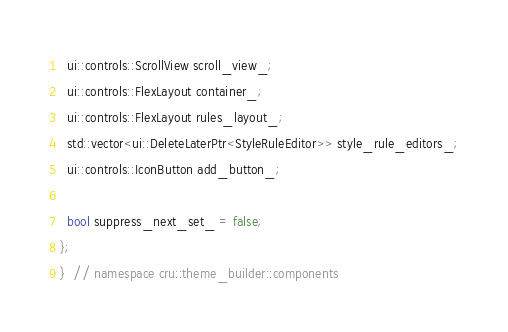Convert code to text. <code><loc_0><loc_0><loc_500><loc_500><_C_>  ui::controls::ScrollView scroll_view_;
  ui::controls::FlexLayout container_;
  ui::controls::FlexLayout rules_layout_;
  std::vector<ui::DeleteLaterPtr<StyleRuleEditor>> style_rule_editors_;
  ui::controls::IconButton add_button_;

  bool suppress_next_set_ = false;
};
}  // namespace cru::theme_builder::components
</code> 